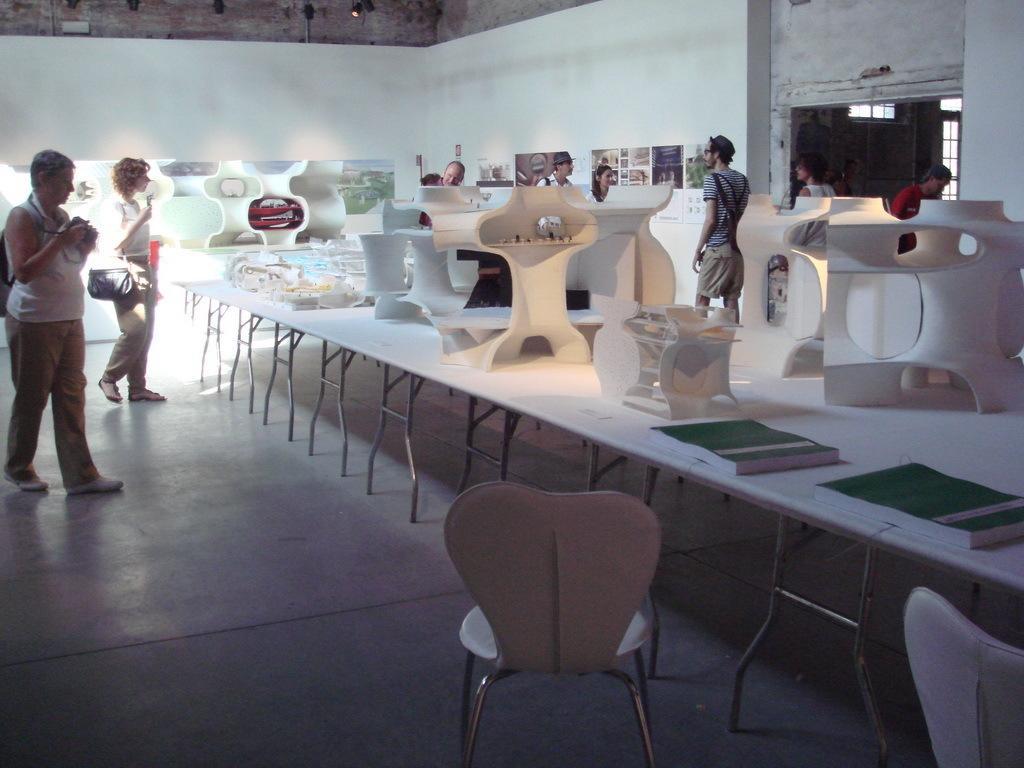Can you describe this image briefly? This is a dining room, there are group of persons in this dining room at the left side of the image there are two women one is carrying a backpack and holding a object and the other woman is carrying a hand bag and at the right side of the image there is a man wearing red color T-shirt and at the middle there is a man who is wearing a T-shirt and a cap and there is a chair at the bottom of the image and at the right side of the image there is a book 